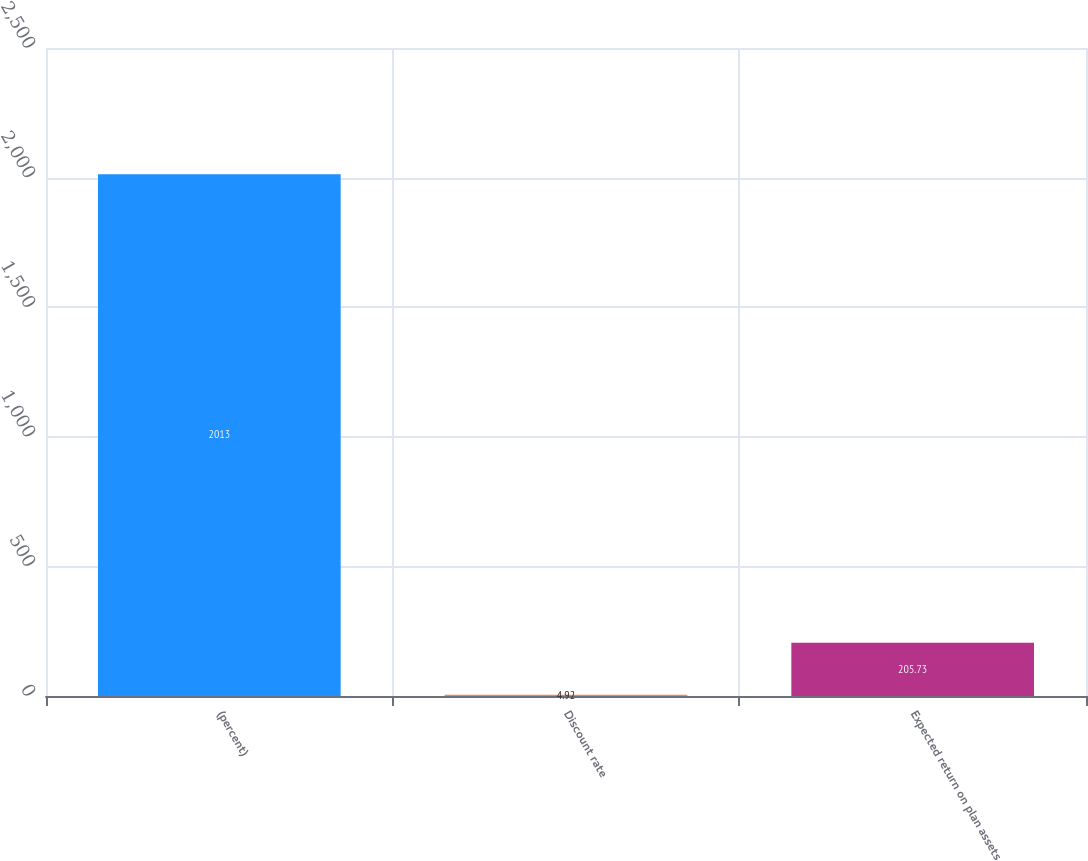<chart> <loc_0><loc_0><loc_500><loc_500><bar_chart><fcel>(percent)<fcel>Discount rate<fcel>Expected return on plan assets<nl><fcel>2013<fcel>4.92<fcel>205.73<nl></chart> 